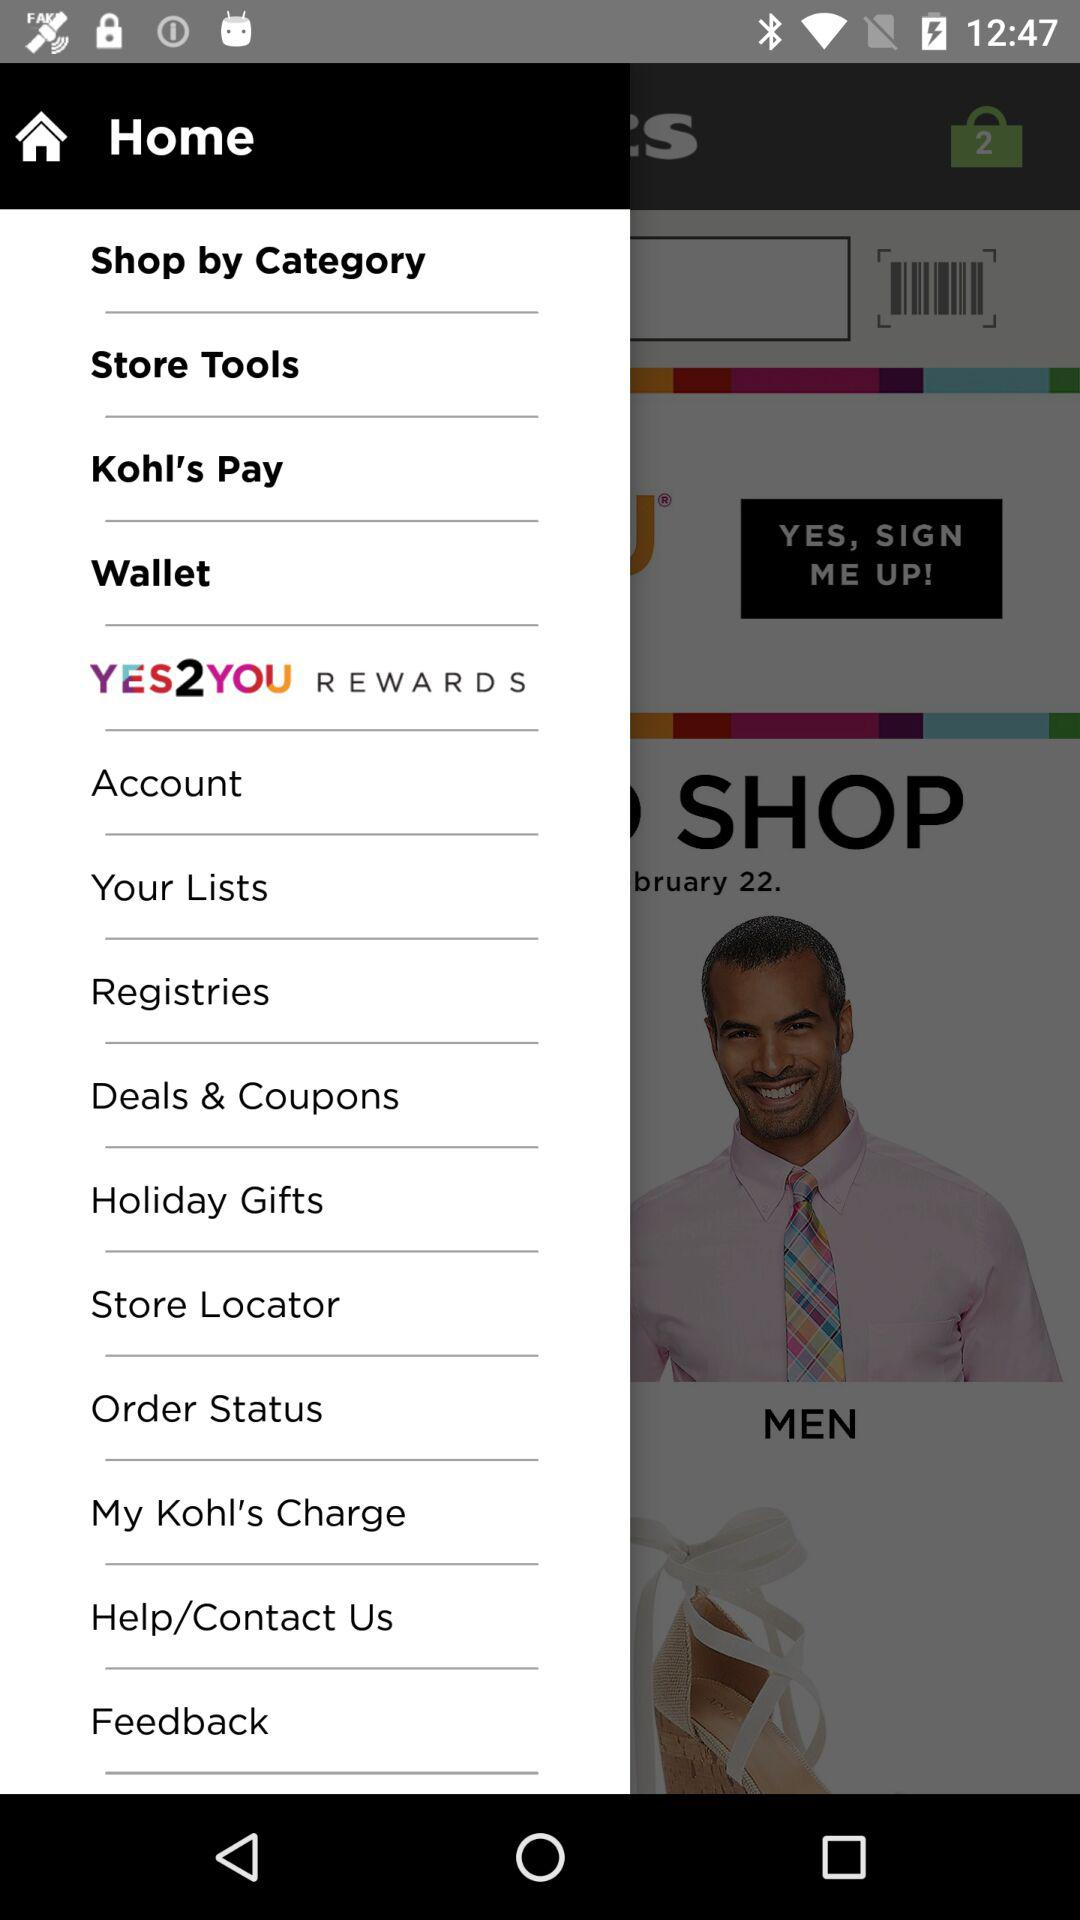Which categories are provided for shopping?
When the provided information is insufficient, respond with <no answer>. <no answer> 